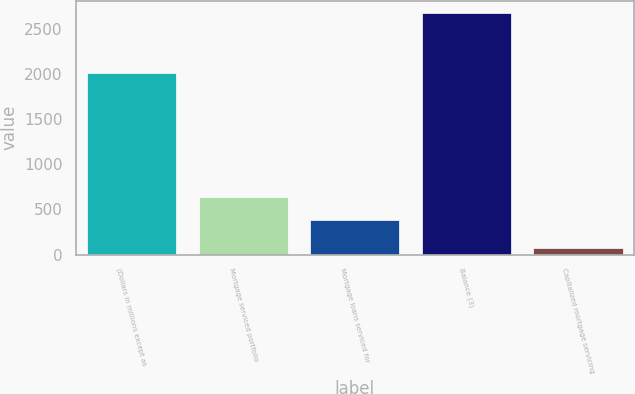Convert chart. <chart><loc_0><loc_0><loc_500><loc_500><bar_chart><fcel>(Dollars in millions except as<fcel>Mortgage serviced portfolio<fcel>Mortgage loans serviced for<fcel>Balance (3)<fcel>Capitalized mortgage servicing<nl><fcel>2015<fcel>638.9<fcel>378<fcel>2680<fcel>71<nl></chart> 